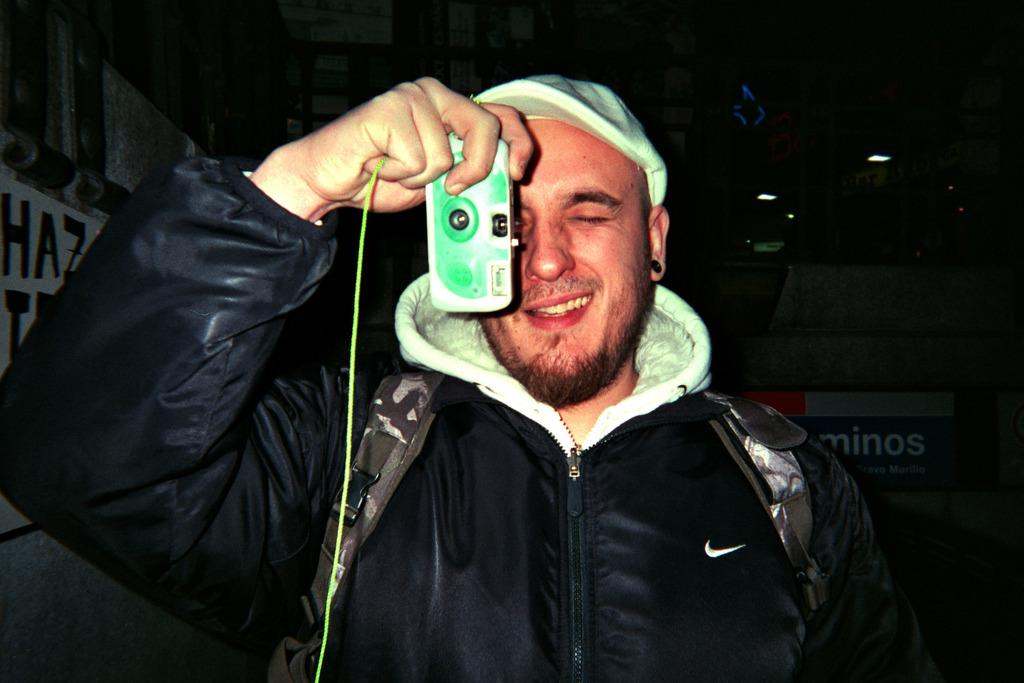Who is present in the image? There is a man in the image. What is the man doing in the image? The man is smiling and holding a camera with his hand. What can be seen in the background of the image? There are lights, posters, and some objects visible in the background. How would you describe the background of the image? The background is dark. What is the man's belief about the texture of the border in the image? There is no mention of texture or border in the image, so it is not possible to determine the man's belief about them. 